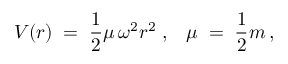Convert formula to latex. <formula><loc_0><loc_0><loc_500><loc_500>V ( r ) \, = \, \frac { 1 } { 2 } \mu \, \omega ^ { 2 } r ^ { 2 } \, , \, \mu \, = \, \frac { 1 } { 2 } m \, ,</formula> 